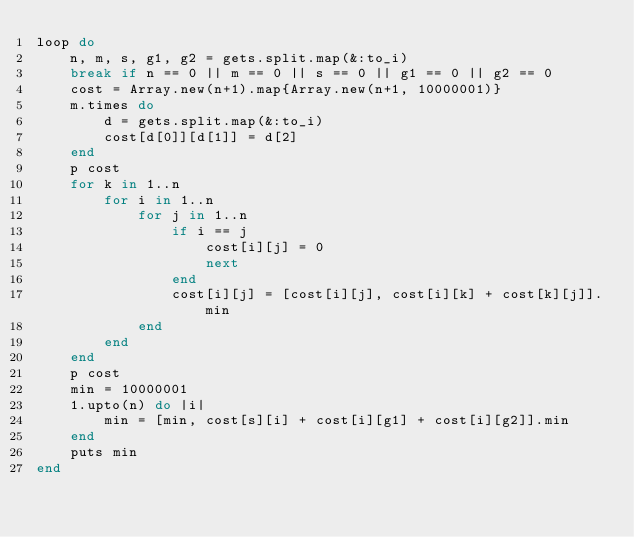<code> <loc_0><loc_0><loc_500><loc_500><_Ruby_>loop do
    n, m, s, g1, g2 = gets.split.map(&:to_i)
    break if n == 0 || m == 0 || s == 0 || g1 == 0 || g2 == 0
    cost = Array.new(n+1).map{Array.new(n+1, 10000001)}
    m.times do
        d = gets.split.map(&:to_i)
        cost[d[0]][d[1]] = d[2]
    end
    p cost
    for k in 1..n
        for i in 1..n
            for j in 1..n
                if i == j
                    cost[i][j] = 0
                    next
                end
                cost[i][j] = [cost[i][j], cost[i][k] + cost[k][j]].min
            end
        end
    end
    p cost
    min = 10000001
    1.upto(n) do |i|
        min = [min, cost[s][i] + cost[i][g1] + cost[i][g2]].min
    end
    puts min
end</code> 